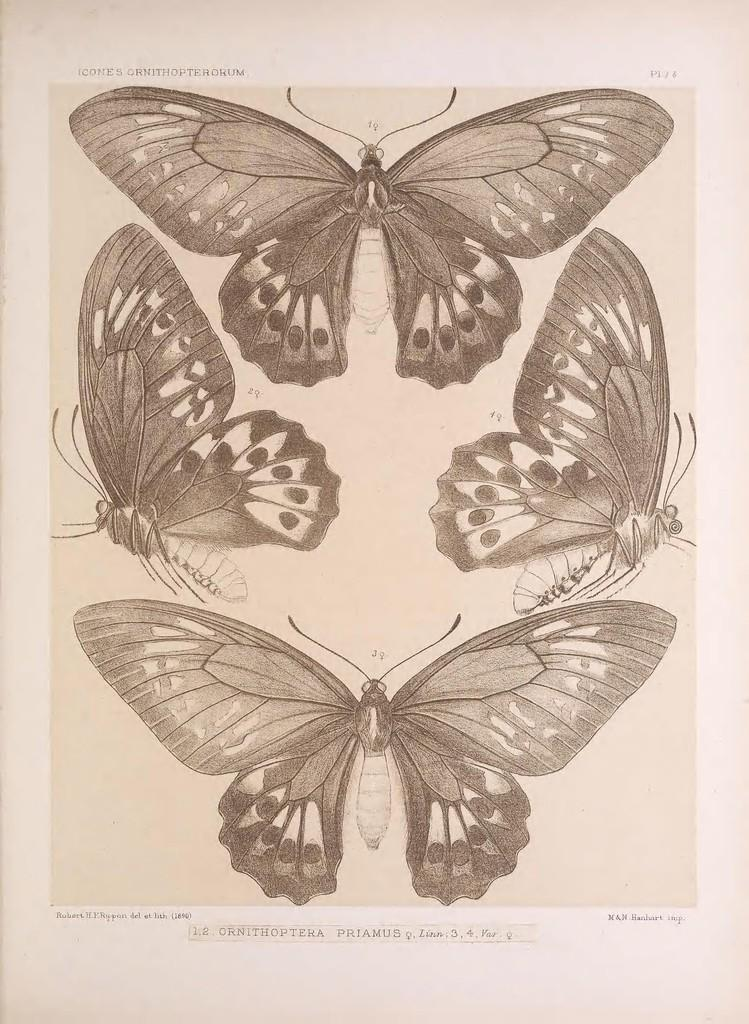What is depicted in the drawing in the image? There is a drawing of four butterflies in the image. What else can be seen in the image besides the drawing? There is text at the top and bottom of the image. What type of vein is visible in the image? There is no vein present in the image; it features a drawing of butterflies and text. 